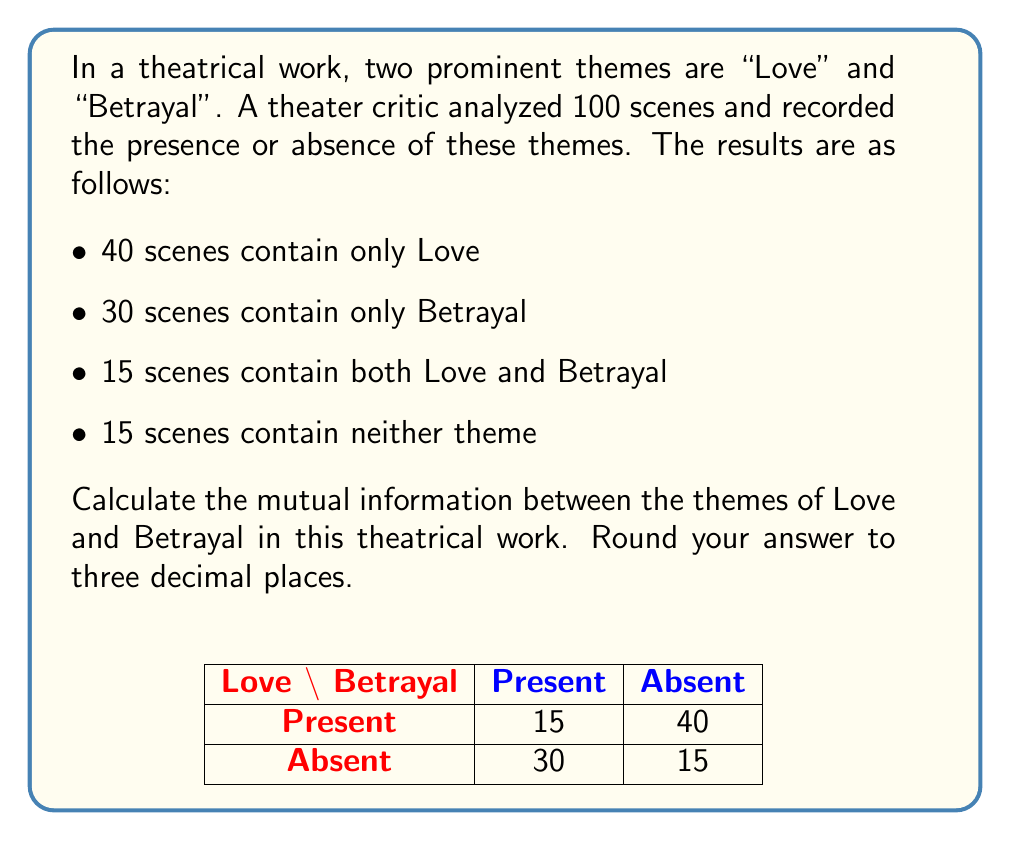Can you solve this math problem? To calculate the mutual information between Love and Betrayal, we'll follow these steps:

1) First, let's define our variables:
   L: presence of Love theme
   B: presence of Betrayal theme

2) Calculate the probabilities:
   $P(L) = (40 + 15) / 100 = 0.55$
   $P(B) = (30 + 15) / 100 = 0.45$
   $P(L, B) = 15 / 100 = 0.15$

3) The mutual information formula is:
   $$I(L;B) = \sum_{l \in L} \sum_{b \in B} P(l,b) \log_2 \frac{P(l,b)}{P(l)P(b)}$$

4) We need to calculate this for all combinations of L and B:

   For L=1, B=1: $P(1,1) \log_2 \frac{P(1,1)}{P(1)P(1)} = 0.15 \log_2 \frac{0.15}{0.55 \cdot 0.45} = 0.0380$
   
   For L=1, B=0: $P(1,0) \log_2 \frac{P(1,0)}{P(1)P(0)} = 0.40 \log_2 \frac{0.40}{0.55 \cdot 0.55} = 0.0445$
   
   For L=0, B=1: $P(0,1) \log_2 \frac{P(0,1)}{P(0)P(1)} = 0.30 \log_2 \frac{0.30}{0.45 \cdot 0.55} = 0.0334$
   
   For L=0, B=0: $P(0,0) \log_2 \frac{P(0,0)}{P(0)P(0)} = 0.15 \log_2 \frac{0.15}{0.45 \cdot 0.55} = 0.0380$

5) Sum all these values:
   $I(L;B) = 0.0380 + 0.0445 + 0.0334 + 0.0380 = 0.1539$

6) Rounding to three decimal places: 0.154 bits
Answer: 0.154 bits 